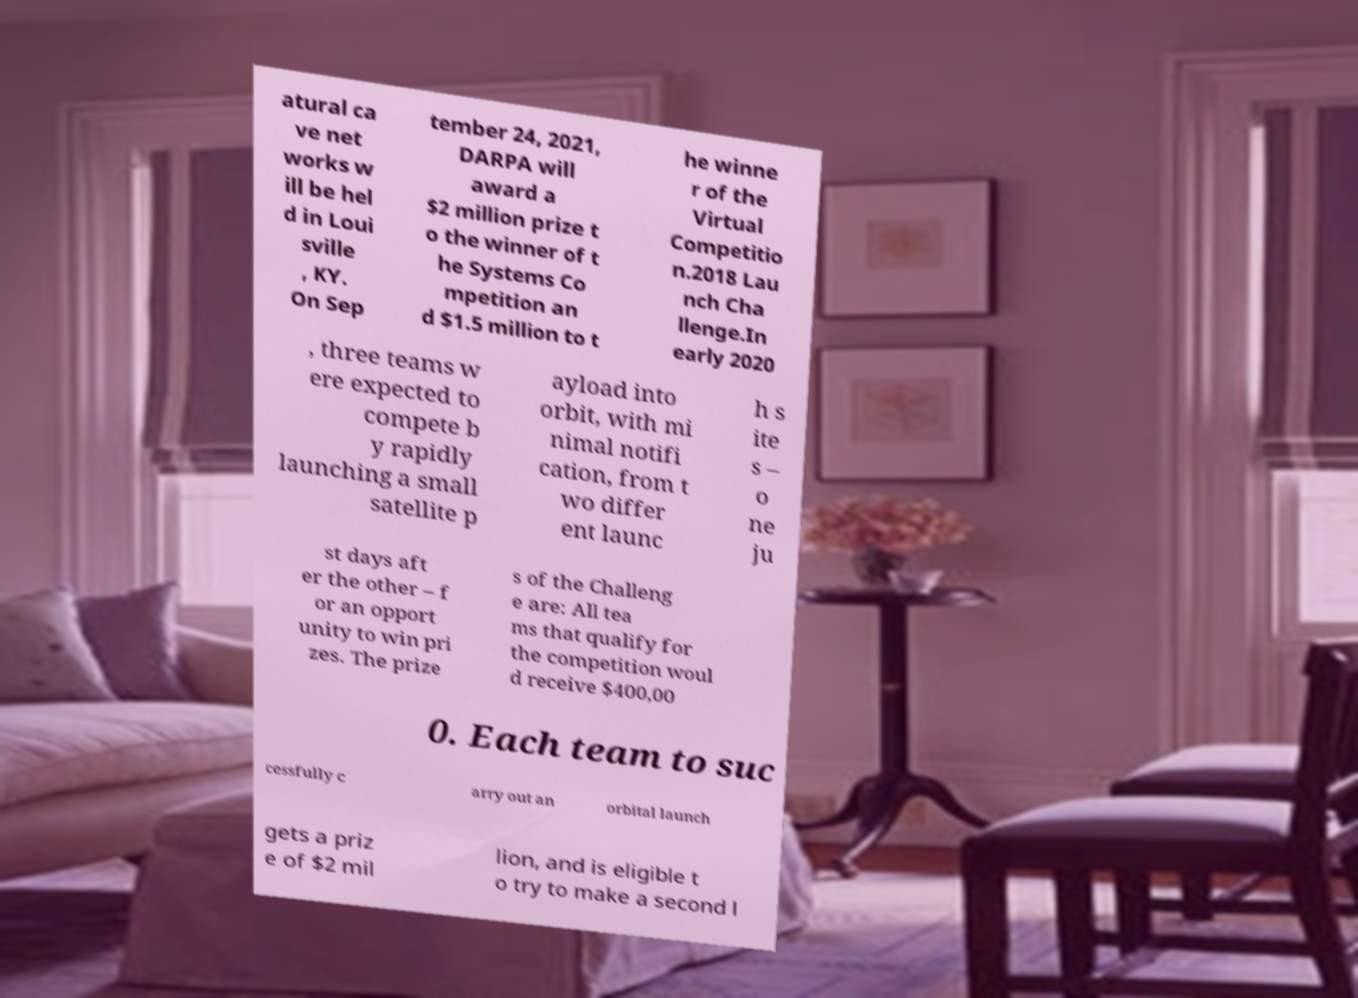There's text embedded in this image that I need extracted. Can you transcribe it verbatim? atural ca ve net works w ill be hel d in Loui sville , KY. On Sep tember 24, 2021, DARPA will award a $2 million prize t o the winner of t he Systems Co mpetition an d $1.5 million to t he winne r of the Virtual Competitio n.2018 Lau nch Cha llenge.In early 2020 , three teams w ere expected to compete b y rapidly launching a small satellite p ayload into orbit, with mi nimal notifi cation, from t wo differ ent launc h s ite s – o ne ju st days aft er the other – f or an opport unity to win pri zes. The prize s of the Challeng e are: All tea ms that qualify for the competition woul d receive $400,00 0. Each team to suc cessfully c arry out an orbital launch gets a priz e of $2 mil lion, and is eligible t o try to make a second l 